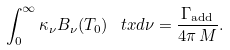<formula> <loc_0><loc_0><loc_500><loc_500>\int _ { 0 } ^ { \infty } \kappa _ { \nu } B _ { \nu } ( T _ { 0 } ) \, \ t x d \nu = \frac { \Gamma _ { \text {add} } } { 4 \pi \, M } .</formula> 